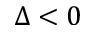<formula> <loc_0><loc_0><loc_500><loc_500>\Delta < 0</formula> 